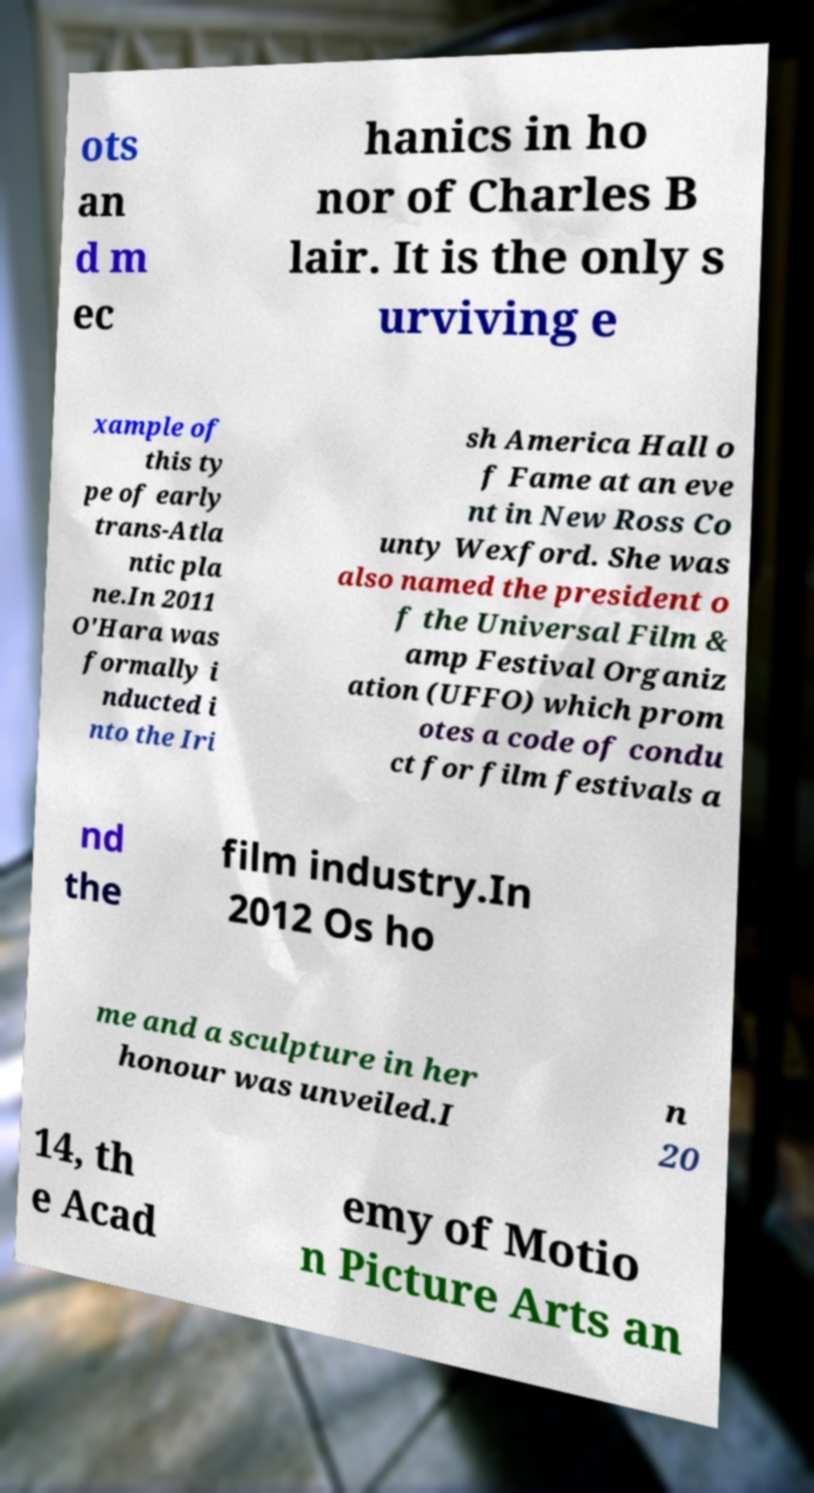For documentation purposes, I need the text within this image transcribed. Could you provide that? ots an d m ec hanics in ho nor of Charles B lair. It is the only s urviving e xample of this ty pe of early trans-Atla ntic pla ne.In 2011 O'Hara was formally i nducted i nto the Iri sh America Hall o f Fame at an eve nt in New Ross Co unty Wexford. She was also named the president o f the Universal Film & amp Festival Organiz ation (UFFO) which prom otes a code of condu ct for film festivals a nd the film industry.In 2012 Os ho me and a sculpture in her honour was unveiled.I n 20 14, th e Acad emy of Motio n Picture Arts an 